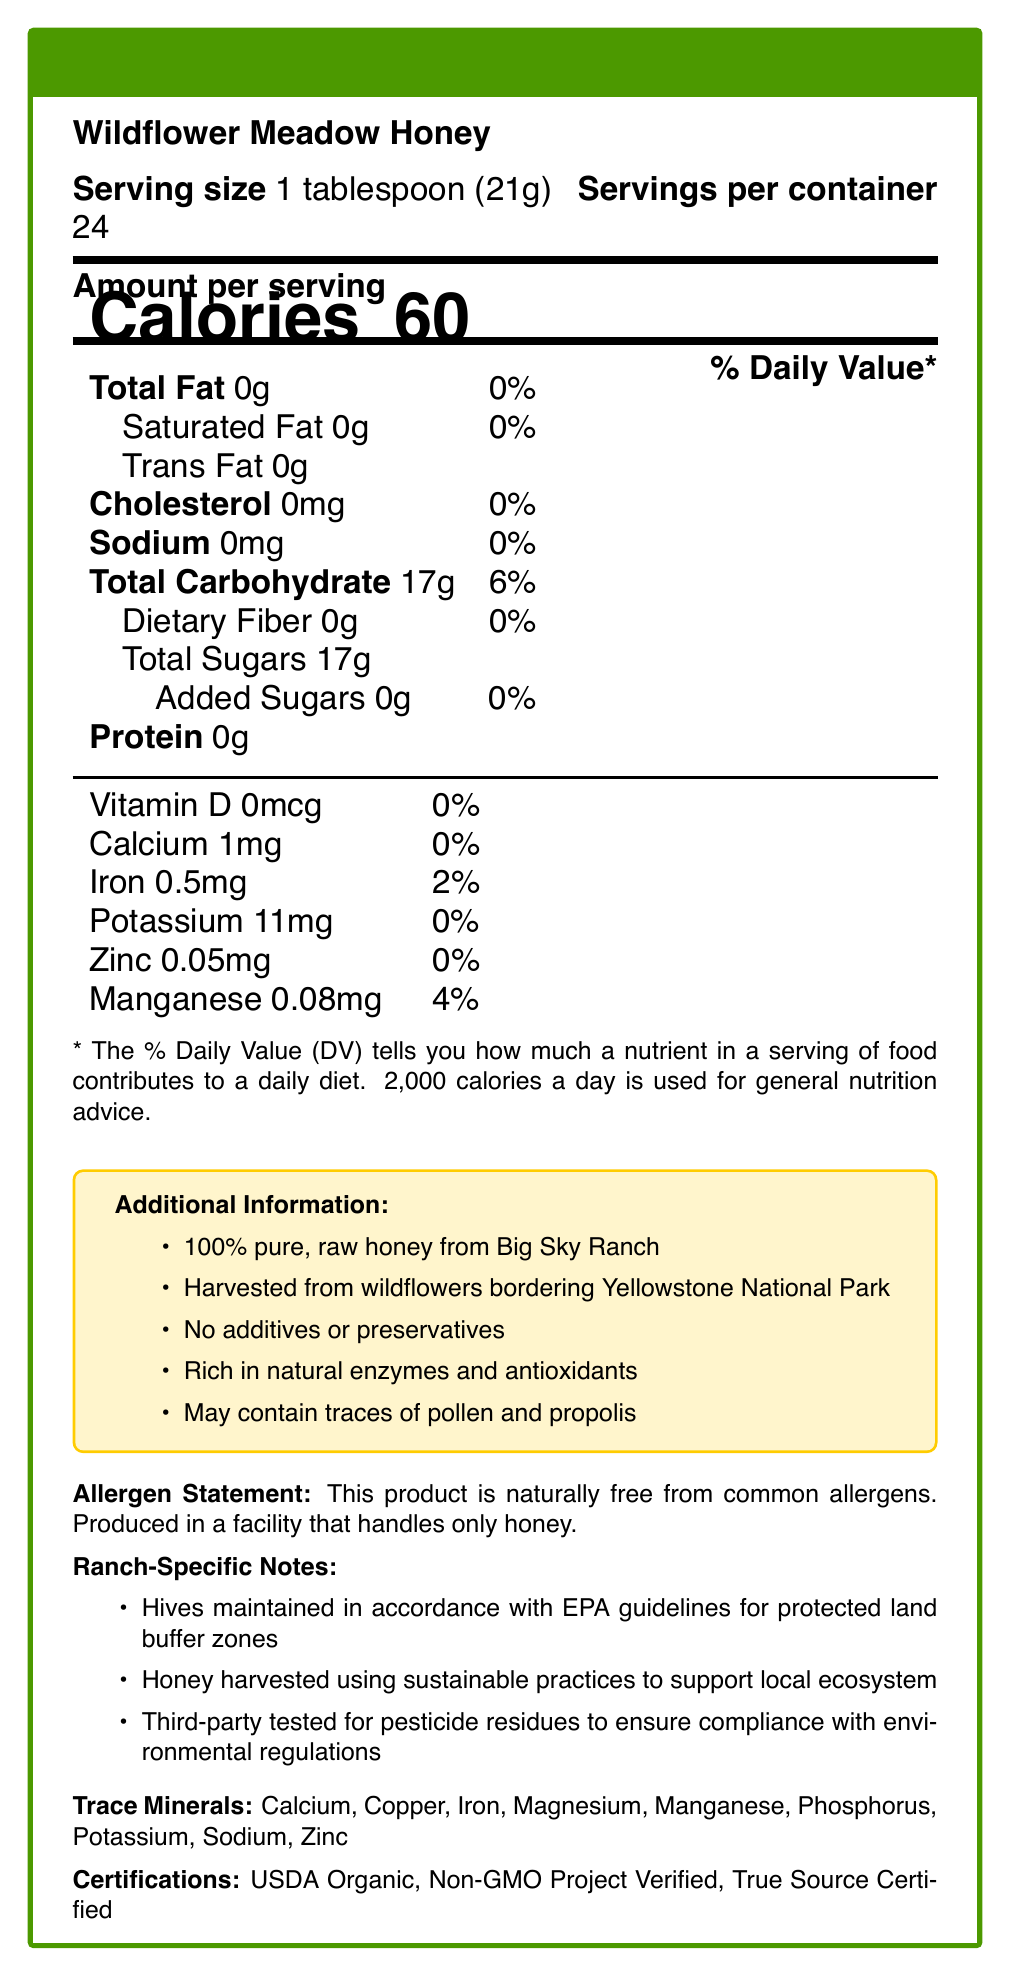What is the serving size for Wildflower Meadow Honey? The serving size is explicitly mentioned in the document as 1 tablespoon (21g).
Answer: 1 tablespoon (21g) How many servings are there per container of Wildflower Meadow Honey? It is stated in the document that there are 24 servings per container.
Answer: 24 What is the total carbohydrate content per serving of Wildflower Meadow Honey? The document lists total carbohydrates as 17g per serving.
Answer: 17g Is Wildflower Meadow Honey free from common allergens? The allergen statement mentions that the product is naturally free from common allergens.
Answer: Yes What are some of the trace minerals found in Wildflower Meadow Honey? The document lists these as the trace minerals present in the honey.
Answer: Calcium, Copper, Iron, Magnesium, Manganese, Phosphorus, Potassium, Sodium, Zinc Which one of these certifications does Wildflower Meadow Honey have? A. Fair Trade Certified B. USDA Organic C. Gluten-Free D. Kosher The document states that the honey is USDA Organic certified.
Answer: B What is the calorie content per serving of Wildflower Meadow Honey? A. 40 calories B. 50 calories C. 60 calories D. 70 calories The document indicates 60 calories per serving.
Answer: C Are there any additives or preservatives in Wildflower Meadow Honey? Under "Additional Information," it states that there are no additives or preservatives.
Answer: No How is the honey harvested to support the local ecosystem? The ranch-specific notes mention that the honey is harvested using sustainable practices to support the local ecosystem.
Answer: Using sustainable practices Does the facility that produces Wildflower Meadow Honey handle other types of food allergens? It is mentioned that the facility handles only honey.
Answer: No Is Wildflower Meadow Honey compliant with environmental regulations? The document states that the honey is third-party tested for pesticide residues to ensure compliance with environmental regulations.
Answer: Yes Summarize the main points of the Nutrition Facts label for Wildflower Meadow Honey. This summary captures the key nutritional aspects, additional information about the product, allergen statement, sustainability practices, and certifications as detailed in the provided document.
Answer: The Nutrition Facts label for Wildflower Meadow Honey provides detailed information about its nutritional content per serving, which is 1 tablespoon (21g). It has 60 calories per serving, no fat, cholesterol, or sodium, and contains 17g of total carbohydrates, all of which are natural sugars. There are no added sugars. The honey contains trace minerals like calcium, iron, potassium, zinc, and manganese. Additionally, the label emphasizes that the honey is 100% pure, raw, and harvested sustainably from wildflowers near Yellowstone National Park. It is free from common allergens, uses no additives or preservatives, and is certified USDA Organic, Non-GMO Project Verified, and True Source Certified. Does Wildflower Meadow Honey contain any dietary fiber? The document lists the dietary fiber content as 0g.
Answer: No What practices are followed to maintain hives in accordance with protected land buffer zones? This practice is specified in the ranch-specific notes.
Answer: Hives are maintained in accordance with EPA guidelines for protected land buffer zones What is the total amount of sugars per serving in Wildflower Meadow Honey? The total sugars, which are natural, amount to 17g per serving.
Answer: 17g What is the iron content per serving of Wildflower Meadow Honey? The document lists an iron content of 0.5mg per serving.
Answer: 0.5mg What sources are mentioned verifying the honey's quality and origin? The document lists these three certifications.
Answer: USDA Organic, Non-GMO Project Verified, True Source Certified What are the main differences between this honey and commercially processed honey? The document does not provide a comparison between Wildflower Meadow Honey and commercially processed honey.
Answer: Cannot be determined from the document 